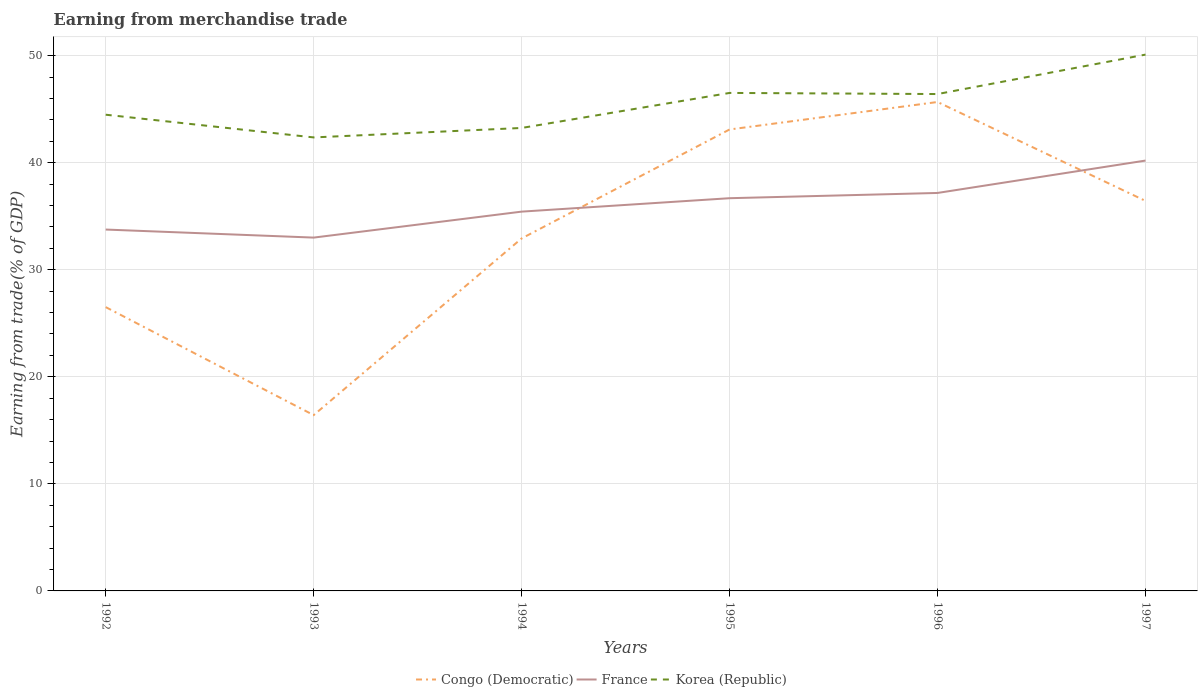How many different coloured lines are there?
Keep it short and to the point. 3. Across all years, what is the maximum earnings from trade in Korea (Republic)?
Keep it short and to the point. 42.36. What is the total earnings from trade in Korea (Republic) in the graph?
Your answer should be very brief. -1.93. What is the difference between the highest and the second highest earnings from trade in Korea (Republic)?
Keep it short and to the point. 7.74. What is the difference between the highest and the lowest earnings from trade in Korea (Republic)?
Make the answer very short. 3. Is the earnings from trade in France strictly greater than the earnings from trade in Korea (Republic) over the years?
Provide a succinct answer. Yes. How many lines are there?
Offer a very short reply. 3. How many years are there in the graph?
Provide a succinct answer. 6. What is the difference between two consecutive major ticks on the Y-axis?
Keep it short and to the point. 10. Does the graph contain any zero values?
Your answer should be very brief. No. Does the graph contain grids?
Make the answer very short. Yes. How are the legend labels stacked?
Your response must be concise. Horizontal. What is the title of the graph?
Your answer should be very brief. Earning from merchandise trade. What is the label or title of the Y-axis?
Make the answer very short. Earning from trade(% of GDP). What is the Earning from trade(% of GDP) in Congo (Democratic) in 1992?
Make the answer very short. 26.51. What is the Earning from trade(% of GDP) in France in 1992?
Ensure brevity in your answer.  33.75. What is the Earning from trade(% of GDP) of Korea (Republic) in 1992?
Offer a terse response. 44.48. What is the Earning from trade(% of GDP) in Congo (Democratic) in 1993?
Provide a short and direct response. 16.42. What is the Earning from trade(% of GDP) of France in 1993?
Give a very brief answer. 33. What is the Earning from trade(% of GDP) in Korea (Republic) in 1993?
Offer a terse response. 42.36. What is the Earning from trade(% of GDP) in Congo (Democratic) in 1994?
Provide a short and direct response. 32.93. What is the Earning from trade(% of GDP) of France in 1994?
Make the answer very short. 35.43. What is the Earning from trade(% of GDP) of Korea (Republic) in 1994?
Your answer should be compact. 43.24. What is the Earning from trade(% of GDP) in Congo (Democratic) in 1995?
Make the answer very short. 43.1. What is the Earning from trade(% of GDP) of France in 1995?
Ensure brevity in your answer.  36.68. What is the Earning from trade(% of GDP) in Korea (Republic) in 1995?
Your answer should be very brief. 46.52. What is the Earning from trade(% of GDP) of Congo (Democratic) in 1996?
Ensure brevity in your answer.  45.67. What is the Earning from trade(% of GDP) of France in 1996?
Provide a succinct answer. 37.17. What is the Earning from trade(% of GDP) in Korea (Republic) in 1996?
Make the answer very short. 46.41. What is the Earning from trade(% of GDP) in Congo (Democratic) in 1997?
Give a very brief answer. 36.43. What is the Earning from trade(% of GDP) in France in 1997?
Make the answer very short. 40.2. What is the Earning from trade(% of GDP) of Korea (Republic) in 1997?
Offer a terse response. 50.1. Across all years, what is the maximum Earning from trade(% of GDP) in Congo (Democratic)?
Provide a succinct answer. 45.67. Across all years, what is the maximum Earning from trade(% of GDP) in France?
Your response must be concise. 40.2. Across all years, what is the maximum Earning from trade(% of GDP) of Korea (Republic)?
Your answer should be compact. 50.1. Across all years, what is the minimum Earning from trade(% of GDP) in Congo (Democratic)?
Your answer should be compact. 16.42. Across all years, what is the minimum Earning from trade(% of GDP) of France?
Your answer should be very brief. 33. Across all years, what is the minimum Earning from trade(% of GDP) of Korea (Republic)?
Make the answer very short. 42.36. What is the total Earning from trade(% of GDP) of Congo (Democratic) in the graph?
Make the answer very short. 201.06. What is the total Earning from trade(% of GDP) of France in the graph?
Offer a terse response. 216.24. What is the total Earning from trade(% of GDP) in Korea (Republic) in the graph?
Offer a very short reply. 273.11. What is the difference between the Earning from trade(% of GDP) of Congo (Democratic) in 1992 and that in 1993?
Offer a terse response. 10.09. What is the difference between the Earning from trade(% of GDP) of France in 1992 and that in 1993?
Make the answer very short. 0.75. What is the difference between the Earning from trade(% of GDP) of Korea (Republic) in 1992 and that in 1993?
Your answer should be very brief. 2.12. What is the difference between the Earning from trade(% of GDP) of Congo (Democratic) in 1992 and that in 1994?
Your answer should be compact. -6.42. What is the difference between the Earning from trade(% of GDP) of France in 1992 and that in 1994?
Ensure brevity in your answer.  -1.67. What is the difference between the Earning from trade(% of GDP) in Korea (Republic) in 1992 and that in 1994?
Provide a succinct answer. 1.24. What is the difference between the Earning from trade(% of GDP) of Congo (Democratic) in 1992 and that in 1995?
Provide a succinct answer. -16.59. What is the difference between the Earning from trade(% of GDP) of France in 1992 and that in 1995?
Your answer should be very brief. -2.93. What is the difference between the Earning from trade(% of GDP) in Korea (Republic) in 1992 and that in 1995?
Ensure brevity in your answer.  -2.03. What is the difference between the Earning from trade(% of GDP) in Congo (Democratic) in 1992 and that in 1996?
Provide a succinct answer. -19.16. What is the difference between the Earning from trade(% of GDP) in France in 1992 and that in 1996?
Give a very brief answer. -3.42. What is the difference between the Earning from trade(% of GDP) in Korea (Republic) in 1992 and that in 1996?
Provide a succinct answer. -1.93. What is the difference between the Earning from trade(% of GDP) in Congo (Democratic) in 1992 and that in 1997?
Give a very brief answer. -9.92. What is the difference between the Earning from trade(% of GDP) of France in 1992 and that in 1997?
Ensure brevity in your answer.  -6.44. What is the difference between the Earning from trade(% of GDP) in Korea (Republic) in 1992 and that in 1997?
Your response must be concise. -5.61. What is the difference between the Earning from trade(% of GDP) in Congo (Democratic) in 1993 and that in 1994?
Offer a terse response. -16.5. What is the difference between the Earning from trade(% of GDP) of France in 1993 and that in 1994?
Your answer should be compact. -2.43. What is the difference between the Earning from trade(% of GDP) of Korea (Republic) in 1993 and that in 1994?
Keep it short and to the point. -0.88. What is the difference between the Earning from trade(% of GDP) in Congo (Democratic) in 1993 and that in 1995?
Your answer should be compact. -26.68. What is the difference between the Earning from trade(% of GDP) of France in 1993 and that in 1995?
Provide a short and direct response. -3.68. What is the difference between the Earning from trade(% of GDP) in Korea (Republic) in 1993 and that in 1995?
Provide a short and direct response. -4.16. What is the difference between the Earning from trade(% of GDP) of Congo (Democratic) in 1993 and that in 1996?
Keep it short and to the point. -29.25. What is the difference between the Earning from trade(% of GDP) of France in 1993 and that in 1996?
Offer a very short reply. -4.17. What is the difference between the Earning from trade(% of GDP) of Korea (Republic) in 1993 and that in 1996?
Your answer should be very brief. -4.05. What is the difference between the Earning from trade(% of GDP) of Congo (Democratic) in 1993 and that in 1997?
Give a very brief answer. -20.01. What is the difference between the Earning from trade(% of GDP) in France in 1993 and that in 1997?
Give a very brief answer. -7.19. What is the difference between the Earning from trade(% of GDP) of Korea (Republic) in 1993 and that in 1997?
Provide a short and direct response. -7.74. What is the difference between the Earning from trade(% of GDP) in Congo (Democratic) in 1994 and that in 1995?
Make the answer very short. -10.18. What is the difference between the Earning from trade(% of GDP) in France in 1994 and that in 1995?
Keep it short and to the point. -1.25. What is the difference between the Earning from trade(% of GDP) in Korea (Republic) in 1994 and that in 1995?
Your answer should be very brief. -3.27. What is the difference between the Earning from trade(% of GDP) of Congo (Democratic) in 1994 and that in 1996?
Ensure brevity in your answer.  -12.74. What is the difference between the Earning from trade(% of GDP) in France in 1994 and that in 1996?
Your answer should be compact. -1.75. What is the difference between the Earning from trade(% of GDP) in Korea (Republic) in 1994 and that in 1996?
Your answer should be very brief. -3.17. What is the difference between the Earning from trade(% of GDP) of Congo (Democratic) in 1994 and that in 1997?
Your response must be concise. -3.51. What is the difference between the Earning from trade(% of GDP) in France in 1994 and that in 1997?
Offer a very short reply. -4.77. What is the difference between the Earning from trade(% of GDP) in Korea (Republic) in 1994 and that in 1997?
Your answer should be very brief. -6.85. What is the difference between the Earning from trade(% of GDP) of Congo (Democratic) in 1995 and that in 1996?
Keep it short and to the point. -2.57. What is the difference between the Earning from trade(% of GDP) of France in 1995 and that in 1996?
Keep it short and to the point. -0.49. What is the difference between the Earning from trade(% of GDP) of Korea (Republic) in 1995 and that in 1996?
Keep it short and to the point. 0.1. What is the difference between the Earning from trade(% of GDP) in Congo (Democratic) in 1995 and that in 1997?
Your response must be concise. 6.67. What is the difference between the Earning from trade(% of GDP) of France in 1995 and that in 1997?
Your answer should be very brief. -3.51. What is the difference between the Earning from trade(% of GDP) of Korea (Republic) in 1995 and that in 1997?
Keep it short and to the point. -3.58. What is the difference between the Earning from trade(% of GDP) of Congo (Democratic) in 1996 and that in 1997?
Your answer should be very brief. 9.24. What is the difference between the Earning from trade(% of GDP) in France in 1996 and that in 1997?
Your answer should be compact. -3.02. What is the difference between the Earning from trade(% of GDP) in Korea (Republic) in 1996 and that in 1997?
Provide a short and direct response. -3.68. What is the difference between the Earning from trade(% of GDP) in Congo (Democratic) in 1992 and the Earning from trade(% of GDP) in France in 1993?
Give a very brief answer. -6.49. What is the difference between the Earning from trade(% of GDP) of Congo (Democratic) in 1992 and the Earning from trade(% of GDP) of Korea (Republic) in 1993?
Your answer should be very brief. -15.85. What is the difference between the Earning from trade(% of GDP) of France in 1992 and the Earning from trade(% of GDP) of Korea (Republic) in 1993?
Give a very brief answer. -8.61. What is the difference between the Earning from trade(% of GDP) in Congo (Democratic) in 1992 and the Earning from trade(% of GDP) in France in 1994?
Offer a very short reply. -8.92. What is the difference between the Earning from trade(% of GDP) in Congo (Democratic) in 1992 and the Earning from trade(% of GDP) in Korea (Republic) in 1994?
Keep it short and to the point. -16.73. What is the difference between the Earning from trade(% of GDP) in France in 1992 and the Earning from trade(% of GDP) in Korea (Republic) in 1994?
Offer a terse response. -9.49. What is the difference between the Earning from trade(% of GDP) of Congo (Democratic) in 1992 and the Earning from trade(% of GDP) of France in 1995?
Your answer should be compact. -10.17. What is the difference between the Earning from trade(% of GDP) of Congo (Democratic) in 1992 and the Earning from trade(% of GDP) of Korea (Republic) in 1995?
Keep it short and to the point. -20.01. What is the difference between the Earning from trade(% of GDP) in France in 1992 and the Earning from trade(% of GDP) in Korea (Republic) in 1995?
Your response must be concise. -12.76. What is the difference between the Earning from trade(% of GDP) in Congo (Democratic) in 1992 and the Earning from trade(% of GDP) in France in 1996?
Your answer should be compact. -10.66. What is the difference between the Earning from trade(% of GDP) in Congo (Democratic) in 1992 and the Earning from trade(% of GDP) in Korea (Republic) in 1996?
Your answer should be very brief. -19.9. What is the difference between the Earning from trade(% of GDP) of France in 1992 and the Earning from trade(% of GDP) of Korea (Republic) in 1996?
Provide a short and direct response. -12.66. What is the difference between the Earning from trade(% of GDP) in Congo (Democratic) in 1992 and the Earning from trade(% of GDP) in France in 1997?
Ensure brevity in your answer.  -13.69. What is the difference between the Earning from trade(% of GDP) in Congo (Democratic) in 1992 and the Earning from trade(% of GDP) in Korea (Republic) in 1997?
Your response must be concise. -23.59. What is the difference between the Earning from trade(% of GDP) of France in 1992 and the Earning from trade(% of GDP) of Korea (Republic) in 1997?
Offer a very short reply. -16.34. What is the difference between the Earning from trade(% of GDP) in Congo (Democratic) in 1993 and the Earning from trade(% of GDP) in France in 1994?
Keep it short and to the point. -19.01. What is the difference between the Earning from trade(% of GDP) of Congo (Democratic) in 1993 and the Earning from trade(% of GDP) of Korea (Republic) in 1994?
Your answer should be compact. -26.82. What is the difference between the Earning from trade(% of GDP) of France in 1993 and the Earning from trade(% of GDP) of Korea (Republic) in 1994?
Your response must be concise. -10.24. What is the difference between the Earning from trade(% of GDP) of Congo (Democratic) in 1993 and the Earning from trade(% of GDP) of France in 1995?
Offer a very short reply. -20.26. What is the difference between the Earning from trade(% of GDP) in Congo (Democratic) in 1993 and the Earning from trade(% of GDP) in Korea (Republic) in 1995?
Your answer should be compact. -30.1. What is the difference between the Earning from trade(% of GDP) in France in 1993 and the Earning from trade(% of GDP) in Korea (Republic) in 1995?
Keep it short and to the point. -13.51. What is the difference between the Earning from trade(% of GDP) in Congo (Democratic) in 1993 and the Earning from trade(% of GDP) in France in 1996?
Your answer should be very brief. -20.75. What is the difference between the Earning from trade(% of GDP) in Congo (Democratic) in 1993 and the Earning from trade(% of GDP) in Korea (Republic) in 1996?
Ensure brevity in your answer.  -29.99. What is the difference between the Earning from trade(% of GDP) in France in 1993 and the Earning from trade(% of GDP) in Korea (Republic) in 1996?
Provide a short and direct response. -13.41. What is the difference between the Earning from trade(% of GDP) of Congo (Democratic) in 1993 and the Earning from trade(% of GDP) of France in 1997?
Offer a very short reply. -23.78. What is the difference between the Earning from trade(% of GDP) of Congo (Democratic) in 1993 and the Earning from trade(% of GDP) of Korea (Republic) in 1997?
Your answer should be very brief. -33.68. What is the difference between the Earning from trade(% of GDP) in France in 1993 and the Earning from trade(% of GDP) in Korea (Republic) in 1997?
Make the answer very short. -17.09. What is the difference between the Earning from trade(% of GDP) in Congo (Democratic) in 1994 and the Earning from trade(% of GDP) in France in 1995?
Provide a succinct answer. -3.76. What is the difference between the Earning from trade(% of GDP) of Congo (Democratic) in 1994 and the Earning from trade(% of GDP) of Korea (Republic) in 1995?
Give a very brief answer. -13.59. What is the difference between the Earning from trade(% of GDP) of France in 1994 and the Earning from trade(% of GDP) of Korea (Republic) in 1995?
Provide a short and direct response. -11.09. What is the difference between the Earning from trade(% of GDP) of Congo (Democratic) in 1994 and the Earning from trade(% of GDP) of France in 1996?
Provide a short and direct response. -4.25. What is the difference between the Earning from trade(% of GDP) in Congo (Democratic) in 1994 and the Earning from trade(% of GDP) in Korea (Republic) in 1996?
Provide a short and direct response. -13.49. What is the difference between the Earning from trade(% of GDP) in France in 1994 and the Earning from trade(% of GDP) in Korea (Republic) in 1996?
Your answer should be compact. -10.98. What is the difference between the Earning from trade(% of GDP) in Congo (Democratic) in 1994 and the Earning from trade(% of GDP) in France in 1997?
Provide a succinct answer. -7.27. What is the difference between the Earning from trade(% of GDP) in Congo (Democratic) in 1994 and the Earning from trade(% of GDP) in Korea (Republic) in 1997?
Your answer should be compact. -17.17. What is the difference between the Earning from trade(% of GDP) of France in 1994 and the Earning from trade(% of GDP) of Korea (Republic) in 1997?
Your answer should be very brief. -14.67. What is the difference between the Earning from trade(% of GDP) in Congo (Democratic) in 1995 and the Earning from trade(% of GDP) in France in 1996?
Your response must be concise. 5.93. What is the difference between the Earning from trade(% of GDP) in Congo (Democratic) in 1995 and the Earning from trade(% of GDP) in Korea (Republic) in 1996?
Provide a succinct answer. -3.31. What is the difference between the Earning from trade(% of GDP) in France in 1995 and the Earning from trade(% of GDP) in Korea (Republic) in 1996?
Keep it short and to the point. -9.73. What is the difference between the Earning from trade(% of GDP) of Congo (Democratic) in 1995 and the Earning from trade(% of GDP) of France in 1997?
Your answer should be very brief. 2.9. What is the difference between the Earning from trade(% of GDP) of Congo (Democratic) in 1995 and the Earning from trade(% of GDP) of Korea (Republic) in 1997?
Provide a short and direct response. -6.99. What is the difference between the Earning from trade(% of GDP) of France in 1995 and the Earning from trade(% of GDP) of Korea (Republic) in 1997?
Provide a succinct answer. -13.41. What is the difference between the Earning from trade(% of GDP) of Congo (Democratic) in 1996 and the Earning from trade(% of GDP) of France in 1997?
Your answer should be very brief. 5.47. What is the difference between the Earning from trade(% of GDP) of Congo (Democratic) in 1996 and the Earning from trade(% of GDP) of Korea (Republic) in 1997?
Provide a succinct answer. -4.43. What is the difference between the Earning from trade(% of GDP) of France in 1996 and the Earning from trade(% of GDP) of Korea (Republic) in 1997?
Provide a succinct answer. -12.92. What is the average Earning from trade(% of GDP) of Congo (Democratic) per year?
Ensure brevity in your answer.  33.51. What is the average Earning from trade(% of GDP) in France per year?
Offer a terse response. 36.04. What is the average Earning from trade(% of GDP) of Korea (Republic) per year?
Provide a short and direct response. 45.52. In the year 1992, what is the difference between the Earning from trade(% of GDP) of Congo (Democratic) and Earning from trade(% of GDP) of France?
Your answer should be very brief. -7.25. In the year 1992, what is the difference between the Earning from trade(% of GDP) of Congo (Democratic) and Earning from trade(% of GDP) of Korea (Republic)?
Offer a very short reply. -17.97. In the year 1992, what is the difference between the Earning from trade(% of GDP) of France and Earning from trade(% of GDP) of Korea (Republic)?
Ensure brevity in your answer.  -10.73. In the year 1993, what is the difference between the Earning from trade(% of GDP) of Congo (Democratic) and Earning from trade(% of GDP) of France?
Your answer should be very brief. -16.58. In the year 1993, what is the difference between the Earning from trade(% of GDP) of Congo (Democratic) and Earning from trade(% of GDP) of Korea (Republic)?
Your response must be concise. -25.94. In the year 1993, what is the difference between the Earning from trade(% of GDP) in France and Earning from trade(% of GDP) in Korea (Republic)?
Keep it short and to the point. -9.36. In the year 1994, what is the difference between the Earning from trade(% of GDP) in Congo (Democratic) and Earning from trade(% of GDP) in France?
Ensure brevity in your answer.  -2.5. In the year 1994, what is the difference between the Earning from trade(% of GDP) in Congo (Democratic) and Earning from trade(% of GDP) in Korea (Republic)?
Give a very brief answer. -10.32. In the year 1994, what is the difference between the Earning from trade(% of GDP) in France and Earning from trade(% of GDP) in Korea (Republic)?
Your response must be concise. -7.82. In the year 1995, what is the difference between the Earning from trade(% of GDP) of Congo (Democratic) and Earning from trade(% of GDP) of France?
Offer a terse response. 6.42. In the year 1995, what is the difference between the Earning from trade(% of GDP) of Congo (Democratic) and Earning from trade(% of GDP) of Korea (Republic)?
Your answer should be compact. -3.41. In the year 1995, what is the difference between the Earning from trade(% of GDP) in France and Earning from trade(% of GDP) in Korea (Republic)?
Provide a succinct answer. -9.83. In the year 1996, what is the difference between the Earning from trade(% of GDP) in Congo (Democratic) and Earning from trade(% of GDP) in France?
Make the answer very short. 8.5. In the year 1996, what is the difference between the Earning from trade(% of GDP) in Congo (Democratic) and Earning from trade(% of GDP) in Korea (Republic)?
Your answer should be very brief. -0.74. In the year 1996, what is the difference between the Earning from trade(% of GDP) of France and Earning from trade(% of GDP) of Korea (Republic)?
Your answer should be compact. -9.24. In the year 1997, what is the difference between the Earning from trade(% of GDP) in Congo (Democratic) and Earning from trade(% of GDP) in France?
Make the answer very short. -3.77. In the year 1997, what is the difference between the Earning from trade(% of GDP) in Congo (Democratic) and Earning from trade(% of GDP) in Korea (Republic)?
Provide a succinct answer. -13.67. In the year 1997, what is the difference between the Earning from trade(% of GDP) of France and Earning from trade(% of GDP) of Korea (Republic)?
Your answer should be compact. -9.9. What is the ratio of the Earning from trade(% of GDP) of Congo (Democratic) in 1992 to that in 1993?
Keep it short and to the point. 1.61. What is the ratio of the Earning from trade(% of GDP) in France in 1992 to that in 1993?
Your response must be concise. 1.02. What is the ratio of the Earning from trade(% of GDP) of Korea (Republic) in 1992 to that in 1993?
Provide a short and direct response. 1.05. What is the ratio of the Earning from trade(% of GDP) of Congo (Democratic) in 1992 to that in 1994?
Ensure brevity in your answer.  0.81. What is the ratio of the Earning from trade(% of GDP) of France in 1992 to that in 1994?
Offer a terse response. 0.95. What is the ratio of the Earning from trade(% of GDP) of Korea (Republic) in 1992 to that in 1994?
Provide a succinct answer. 1.03. What is the ratio of the Earning from trade(% of GDP) of Congo (Democratic) in 1992 to that in 1995?
Your response must be concise. 0.61. What is the ratio of the Earning from trade(% of GDP) of France in 1992 to that in 1995?
Your answer should be very brief. 0.92. What is the ratio of the Earning from trade(% of GDP) in Korea (Republic) in 1992 to that in 1995?
Keep it short and to the point. 0.96. What is the ratio of the Earning from trade(% of GDP) of Congo (Democratic) in 1992 to that in 1996?
Make the answer very short. 0.58. What is the ratio of the Earning from trade(% of GDP) in France in 1992 to that in 1996?
Offer a very short reply. 0.91. What is the ratio of the Earning from trade(% of GDP) of Korea (Republic) in 1992 to that in 1996?
Your response must be concise. 0.96. What is the ratio of the Earning from trade(% of GDP) in Congo (Democratic) in 1992 to that in 1997?
Provide a short and direct response. 0.73. What is the ratio of the Earning from trade(% of GDP) in France in 1992 to that in 1997?
Make the answer very short. 0.84. What is the ratio of the Earning from trade(% of GDP) in Korea (Republic) in 1992 to that in 1997?
Keep it short and to the point. 0.89. What is the ratio of the Earning from trade(% of GDP) in Congo (Democratic) in 1993 to that in 1994?
Your answer should be very brief. 0.5. What is the ratio of the Earning from trade(% of GDP) in France in 1993 to that in 1994?
Your answer should be very brief. 0.93. What is the ratio of the Earning from trade(% of GDP) of Korea (Republic) in 1993 to that in 1994?
Your answer should be very brief. 0.98. What is the ratio of the Earning from trade(% of GDP) of Congo (Democratic) in 1993 to that in 1995?
Offer a very short reply. 0.38. What is the ratio of the Earning from trade(% of GDP) of France in 1993 to that in 1995?
Offer a very short reply. 0.9. What is the ratio of the Earning from trade(% of GDP) of Korea (Republic) in 1993 to that in 1995?
Make the answer very short. 0.91. What is the ratio of the Earning from trade(% of GDP) of Congo (Democratic) in 1993 to that in 1996?
Your response must be concise. 0.36. What is the ratio of the Earning from trade(% of GDP) in France in 1993 to that in 1996?
Ensure brevity in your answer.  0.89. What is the ratio of the Earning from trade(% of GDP) of Korea (Republic) in 1993 to that in 1996?
Your answer should be very brief. 0.91. What is the ratio of the Earning from trade(% of GDP) of Congo (Democratic) in 1993 to that in 1997?
Provide a succinct answer. 0.45. What is the ratio of the Earning from trade(% of GDP) of France in 1993 to that in 1997?
Make the answer very short. 0.82. What is the ratio of the Earning from trade(% of GDP) of Korea (Republic) in 1993 to that in 1997?
Your answer should be compact. 0.85. What is the ratio of the Earning from trade(% of GDP) in Congo (Democratic) in 1994 to that in 1995?
Offer a terse response. 0.76. What is the ratio of the Earning from trade(% of GDP) in France in 1994 to that in 1995?
Your answer should be compact. 0.97. What is the ratio of the Earning from trade(% of GDP) in Korea (Republic) in 1994 to that in 1995?
Ensure brevity in your answer.  0.93. What is the ratio of the Earning from trade(% of GDP) of Congo (Democratic) in 1994 to that in 1996?
Your response must be concise. 0.72. What is the ratio of the Earning from trade(% of GDP) of France in 1994 to that in 1996?
Your response must be concise. 0.95. What is the ratio of the Earning from trade(% of GDP) of Korea (Republic) in 1994 to that in 1996?
Give a very brief answer. 0.93. What is the ratio of the Earning from trade(% of GDP) of Congo (Democratic) in 1994 to that in 1997?
Make the answer very short. 0.9. What is the ratio of the Earning from trade(% of GDP) in France in 1994 to that in 1997?
Your answer should be very brief. 0.88. What is the ratio of the Earning from trade(% of GDP) in Korea (Republic) in 1994 to that in 1997?
Give a very brief answer. 0.86. What is the ratio of the Earning from trade(% of GDP) of Congo (Democratic) in 1995 to that in 1996?
Provide a succinct answer. 0.94. What is the ratio of the Earning from trade(% of GDP) of Korea (Republic) in 1995 to that in 1996?
Your answer should be compact. 1. What is the ratio of the Earning from trade(% of GDP) of Congo (Democratic) in 1995 to that in 1997?
Your response must be concise. 1.18. What is the ratio of the Earning from trade(% of GDP) of France in 1995 to that in 1997?
Ensure brevity in your answer.  0.91. What is the ratio of the Earning from trade(% of GDP) in Korea (Republic) in 1995 to that in 1997?
Your answer should be compact. 0.93. What is the ratio of the Earning from trade(% of GDP) in Congo (Democratic) in 1996 to that in 1997?
Offer a terse response. 1.25. What is the ratio of the Earning from trade(% of GDP) in France in 1996 to that in 1997?
Offer a terse response. 0.92. What is the ratio of the Earning from trade(% of GDP) of Korea (Republic) in 1996 to that in 1997?
Keep it short and to the point. 0.93. What is the difference between the highest and the second highest Earning from trade(% of GDP) of Congo (Democratic)?
Offer a very short reply. 2.57. What is the difference between the highest and the second highest Earning from trade(% of GDP) in France?
Provide a succinct answer. 3.02. What is the difference between the highest and the second highest Earning from trade(% of GDP) of Korea (Republic)?
Ensure brevity in your answer.  3.58. What is the difference between the highest and the lowest Earning from trade(% of GDP) in Congo (Democratic)?
Make the answer very short. 29.25. What is the difference between the highest and the lowest Earning from trade(% of GDP) of France?
Your answer should be very brief. 7.19. What is the difference between the highest and the lowest Earning from trade(% of GDP) of Korea (Republic)?
Your response must be concise. 7.74. 